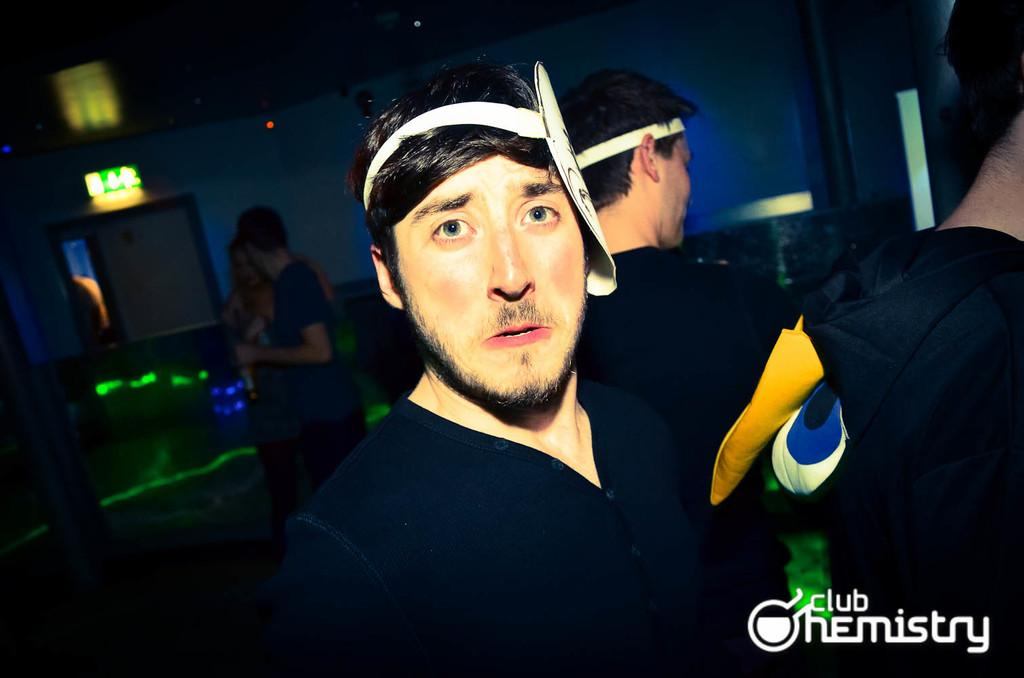What can be seen in the image? There are people in the image. How would you describe the lighting in the image? The image is a little dark. What color are the dresses of the people in the front? The people in the front are wearing black color dresses. What other objects or features can be seen in the image? There are lights and a wall in the image. What type of wrench is being used to fix the wall in the image? There is no wrench present in the image, nor is there any indication of someone fixing the wall. 